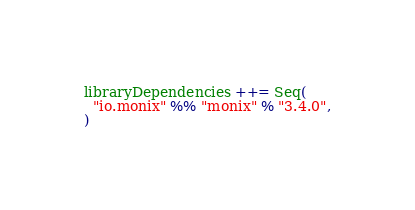Convert code to text. <code><loc_0><loc_0><loc_500><loc_500><_Scala_>libraryDependencies ++= Seq(
  "io.monix" %% "monix" % "3.4.0",
)
</code> 